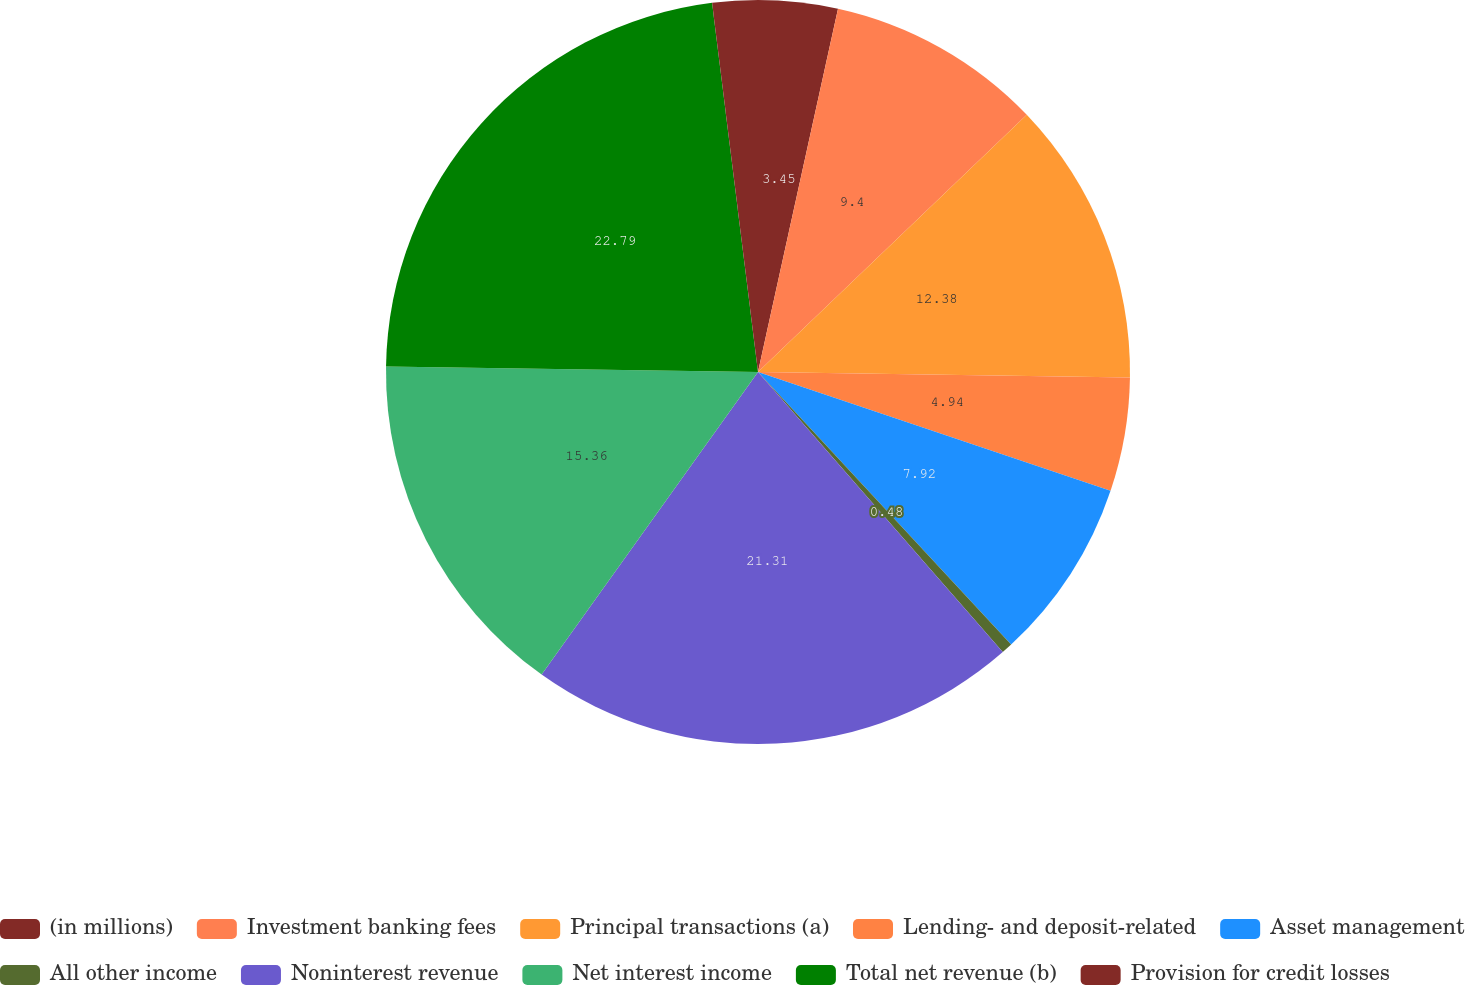<chart> <loc_0><loc_0><loc_500><loc_500><pie_chart><fcel>(in millions)<fcel>Investment banking fees<fcel>Principal transactions (a)<fcel>Lending- and deposit-related<fcel>Asset management<fcel>All other income<fcel>Noninterest revenue<fcel>Net interest income<fcel>Total net revenue (b)<fcel>Provision for credit losses<nl><fcel>3.45%<fcel>9.4%<fcel>12.38%<fcel>4.94%<fcel>7.92%<fcel>0.48%<fcel>21.31%<fcel>15.36%<fcel>22.79%<fcel>1.97%<nl></chart> 